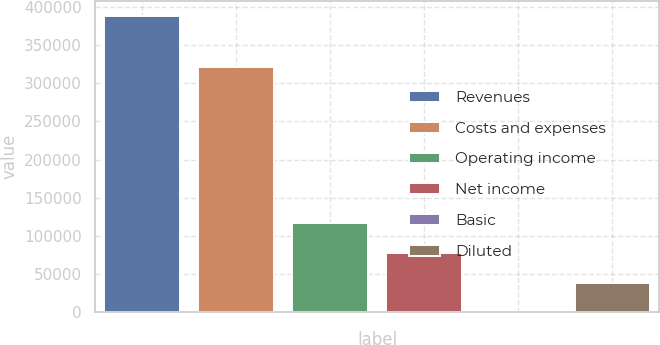Convert chart. <chart><loc_0><loc_0><loc_500><loc_500><bar_chart><fcel>Revenues<fcel>Costs and expenses<fcel>Operating income<fcel>Net income<fcel>Basic<fcel>Diluted<nl><fcel>388112<fcel>321021<fcel>116434<fcel>77622.6<fcel>0.21<fcel>38811.4<nl></chart> 